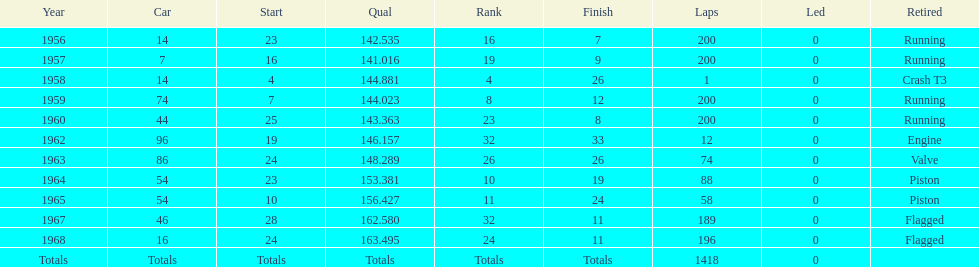What was the last year that it finished the race? 1968. 